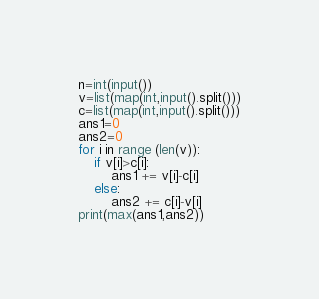Convert code to text. <code><loc_0><loc_0><loc_500><loc_500><_Python_>n=int(input())
v=list(map(int,input().split()))
c=list(map(int,input().split()))
ans1=0
ans2=0
for i in range (len(v)):
    if v[i]>c[i]:
        ans1 += v[i]-c[i]
    else:
        ans2 += c[i]-v[i]
print(max(ans1,ans2))</code> 